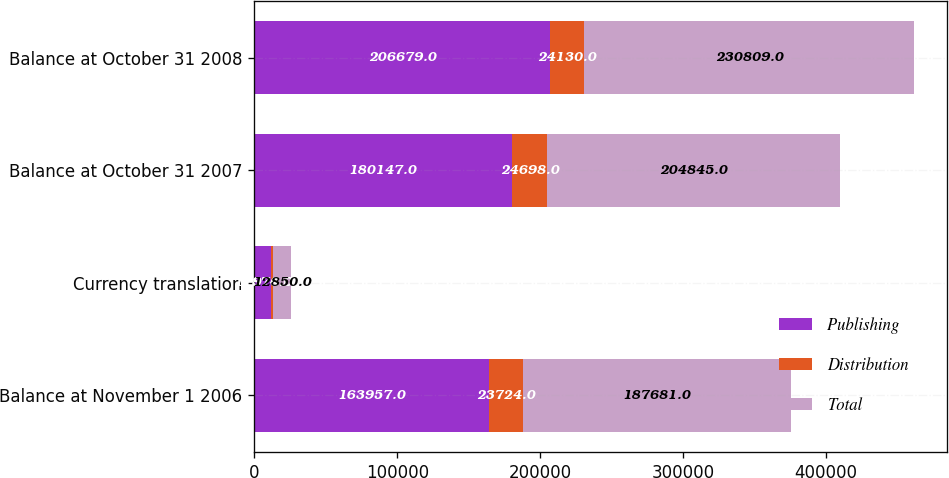Convert chart. <chart><loc_0><loc_0><loc_500><loc_500><stacked_bar_chart><ecel><fcel>Balance at November 1 2006<fcel>Currency translation<fcel>Balance at October 31 2007<fcel>Balance at October 31 2008<nl><fcel>Publishing<fcel>163957<fcel>11876<fcel>180147<fcel>206679<nl><fcel>Distribution<fcel>23724<fcel>974<fcel>24698<fcel>24130<nl><fcel>Total<fcel>187681<fcel>12850<fcel>204845<fcel>230809<nl></chart> 